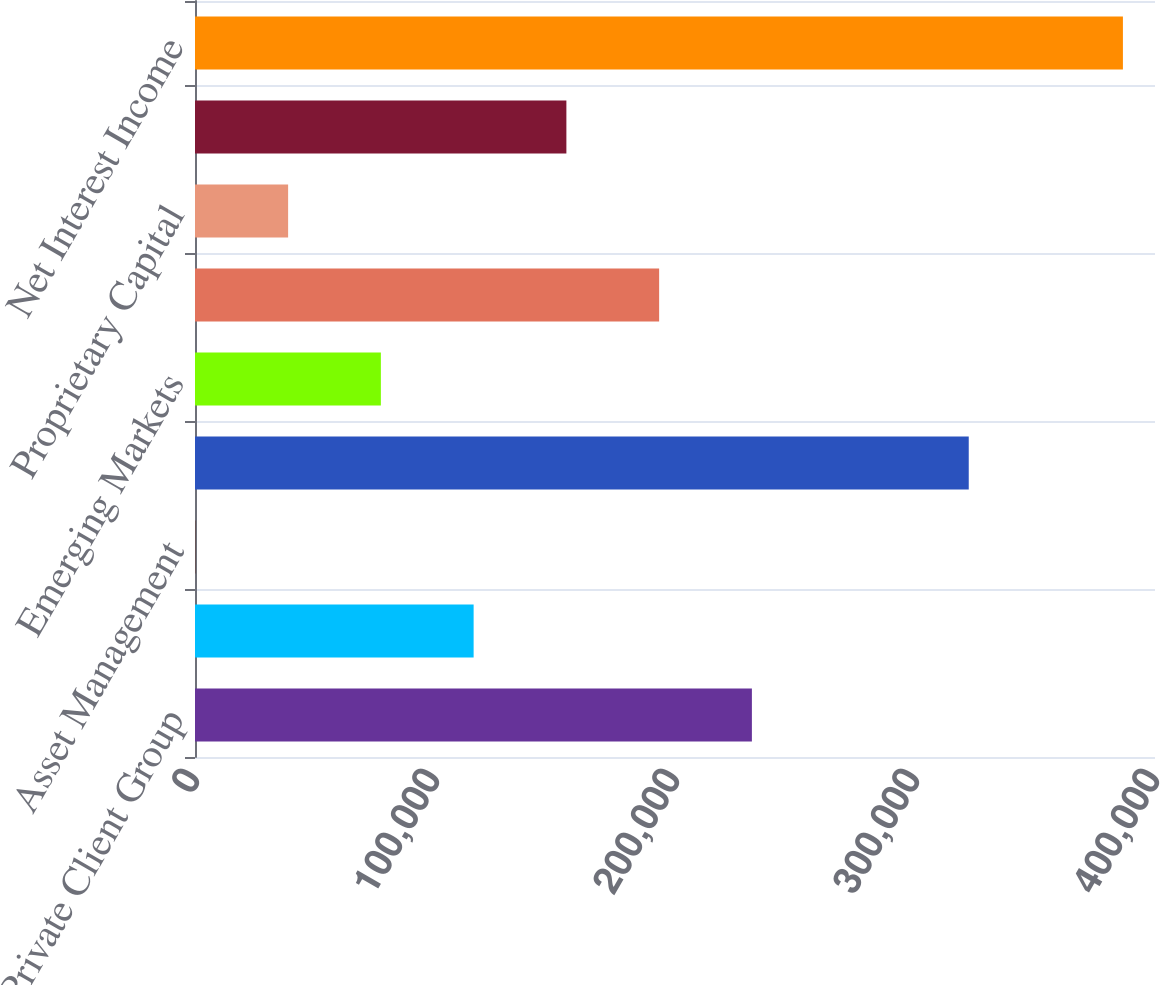Convert chart to OTSL. <chart><loc_0><loc_0><loc_500><loc_500><bar_chart><fcel>Private Client Group<fcel>Capital Markets<fcel>Asset Management<fcel>RJ Bank<fcel>Emerging Markets<fcel>Stock Loan/Borrow<fcel>Proprietary Capital<fcel>Other<fcel>Net Interest Income<nl><fcel>232039<fcel>116095<fcel>151<fcel>322393<fcel>77447<fcel>193391<fcel>38799<fcel>154743<fcel>386631<nl></chart> 